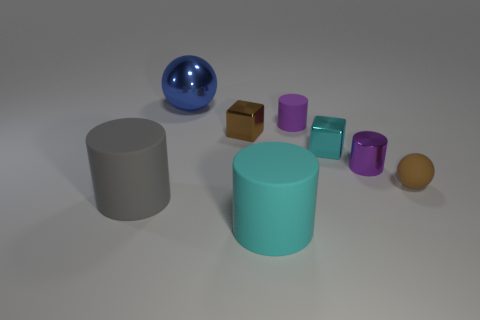Subtract all purple matte cylinders. How many cylinders are left? 3 Subtract all brown cubes. How many cubes are left? 1 Add 1 blue balls. How many objects exist? 9 Subtract 2 cubes. How many cubes are left? 0 Subtract all spheres. How many objects are left? 6 Subtract all rubber things. Subtract all small cylinders. How many objects are left? 2 Add 7 tiny purple metallic things. How many tiny purple metallic things are left? 8 Add 7 big cylinders. How many big cylinders exist? 9 Subtract 1 purple cylinders. How many objects are left? 7 Subtract all cyan cylinders. Subtract all green blocks. How many cylinders are left? 3 